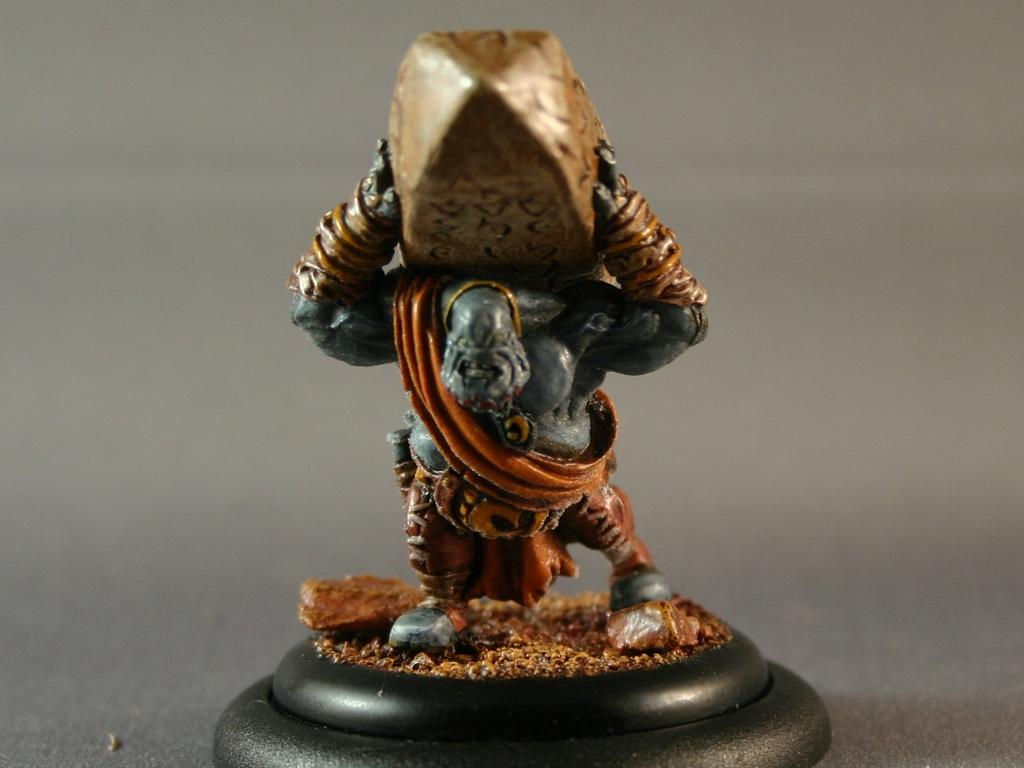What is the main subject of the image? There is a sculpture of a person in the image. What is the person in the sculpture doing? The sculpture depicts a person carrying a stone. Can you describe the background of the image? The background of the image appears blurry. What type of battle is taking place in the image? There is no battle present in the image; it features a sculpture of a person carrying a stone. How many cubs can be seen playing with a bomb in the image? There are no cubs or bombs present in the image. 